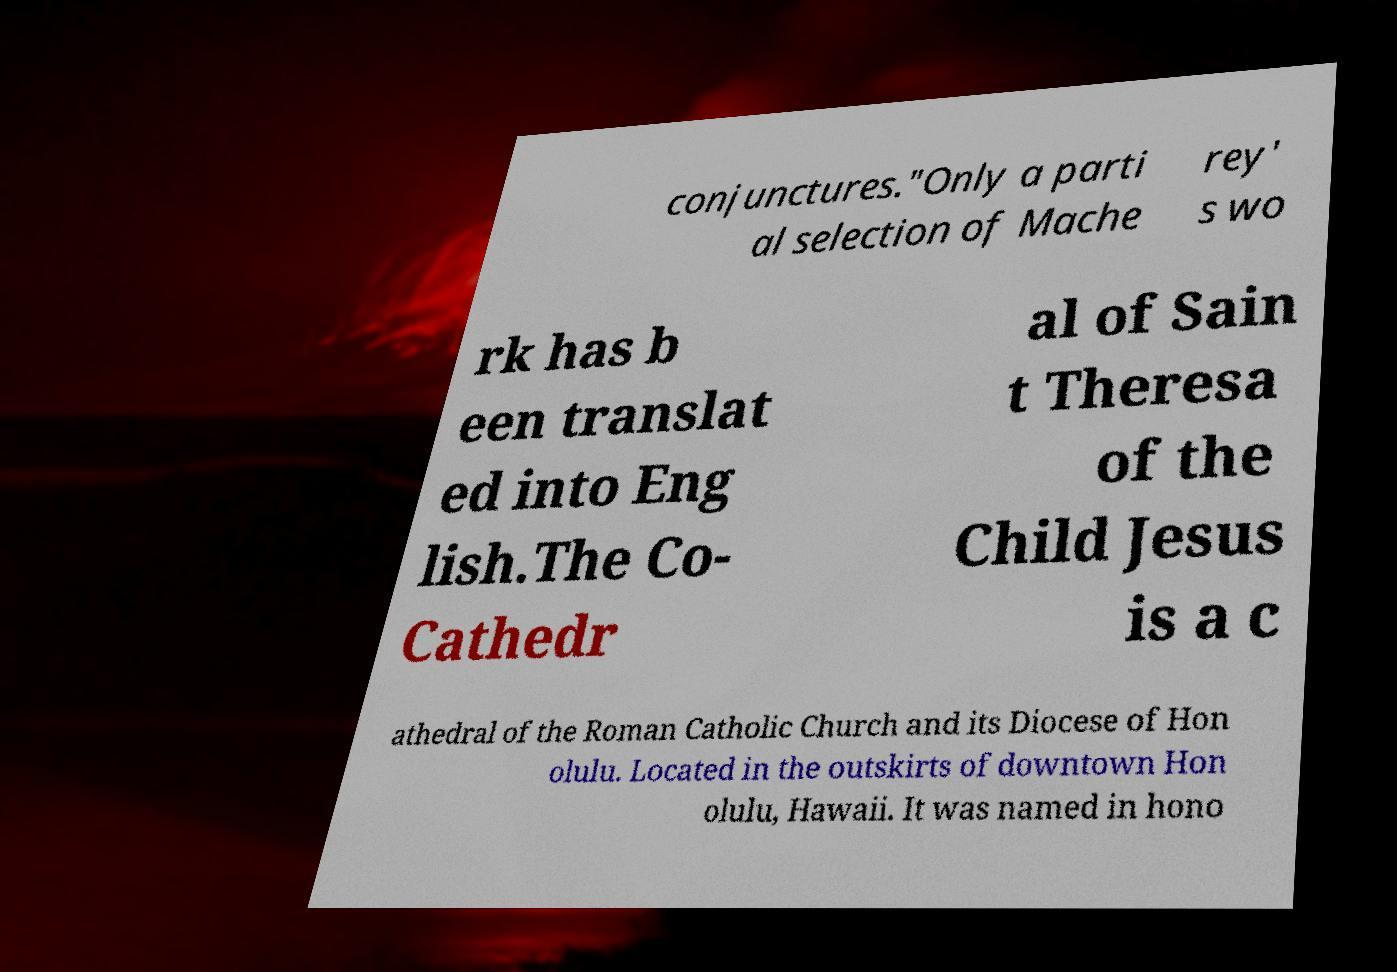There's text embedded in this image that I need extracted. Can you transcribe it verbatim? conjunctures."Only a parti al selection of Mache rey' s wo rk has b een translat ed into Eng lish.The Co- Cathedr al of Sain t Theresa of the Child Jesus is a c athedral of the Roman Catholic Church and its Diocese of Hon olulu. Located in the outskirts of downtown Hon olulu, Hawaii. It was named in hono 